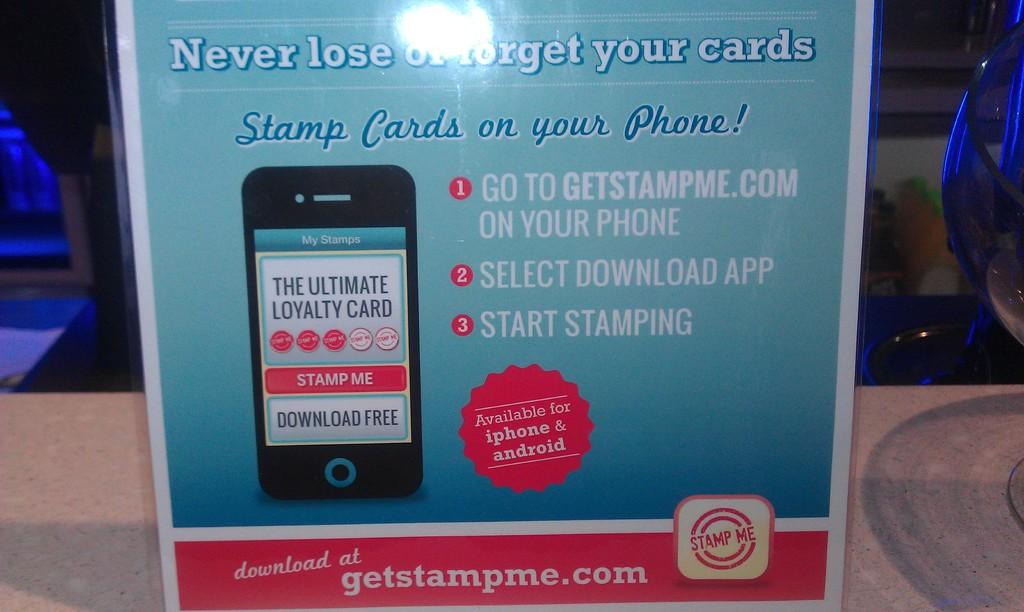<image>
Summarize the visual content of the image. An advertisement for downloading an app from getstampe.com. 